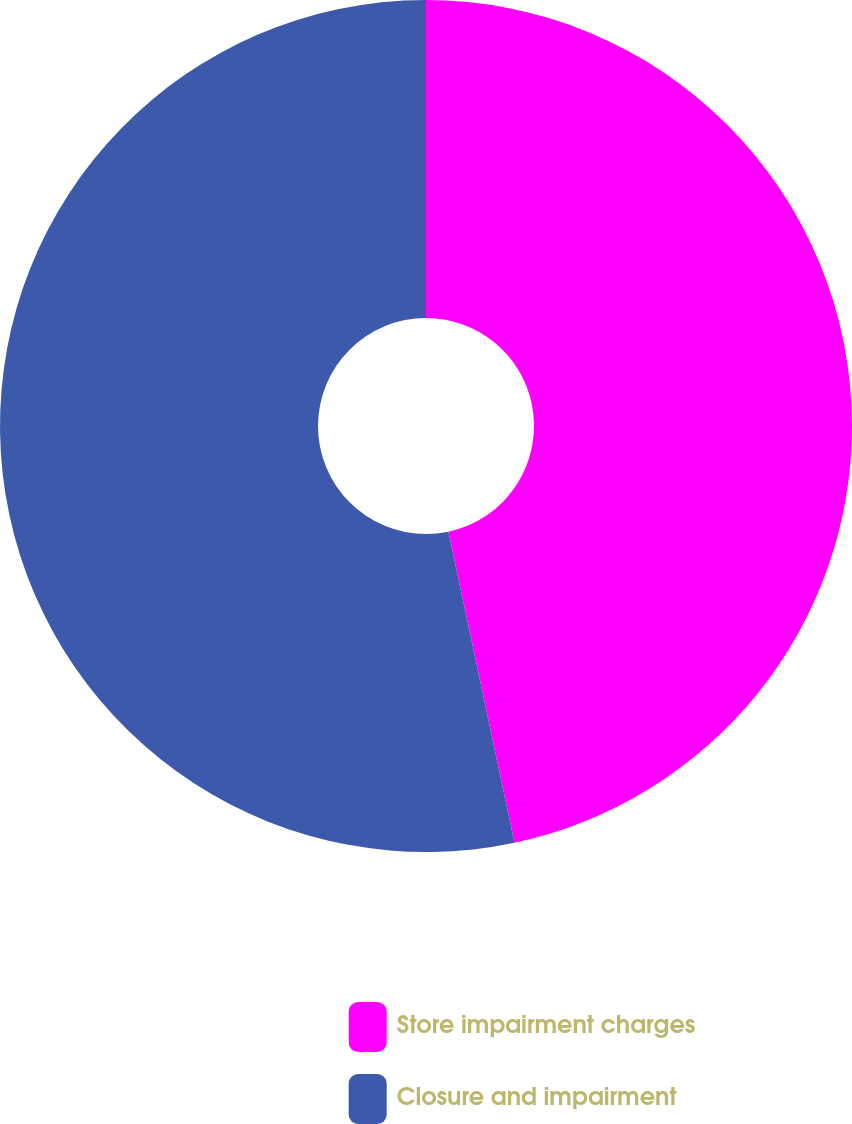Convert chart. <chart><loc_0><loc_0><loc_500><loc_500><pie_chart><fcel>Store impairment charges<fcel>Closure and impairment<nl><fcel>46.67%<fcel>53.33%<nl></chart> 